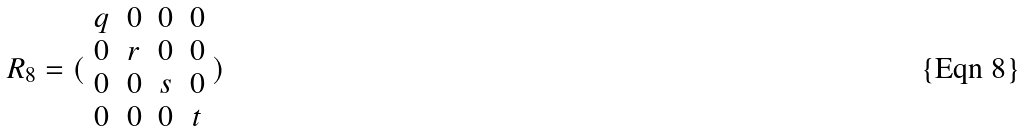<formula> <loc_0><loc_0><loc_500><loc_500>R _ { 8 } = ( \begin{array} { c c c c } q & 0 & 0 & 0 \\ 0 & r & 0 & 0 \\ 0 & 0 & s & 0 \\ 0 & 0 & 0 & t \end{array} )</formula> 